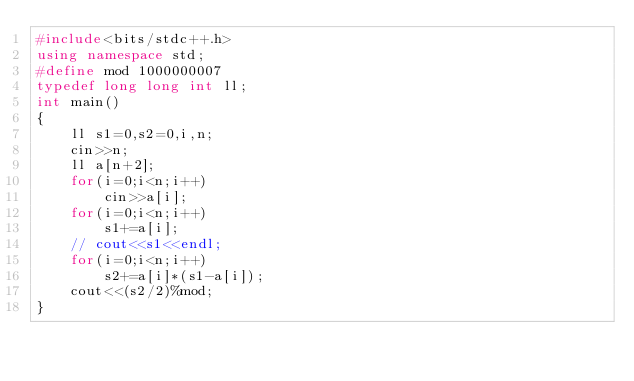Convert code to text. <code><loc_0><loc_0><loc_500><loc_500><_C++_>#include<bits/stdc++.h>
using namespace std;
#define mod 1000000007
typedef long long int ll;
int main()
{
	ll s1=0,s2=0,i,n;
	cin>>n;
	ll a[n+2];
	for(i=0;i<n;i++)
		cin>>a[i];
	for(i=0;i<n;i++)
		s1+=a[i];
	// cout<<s1<<endl;
	for(i=0;i<n;i++)
		s2+=a[i]*(s1-a[i]);
	cout<<(s2/2)%mod;
}</code> 